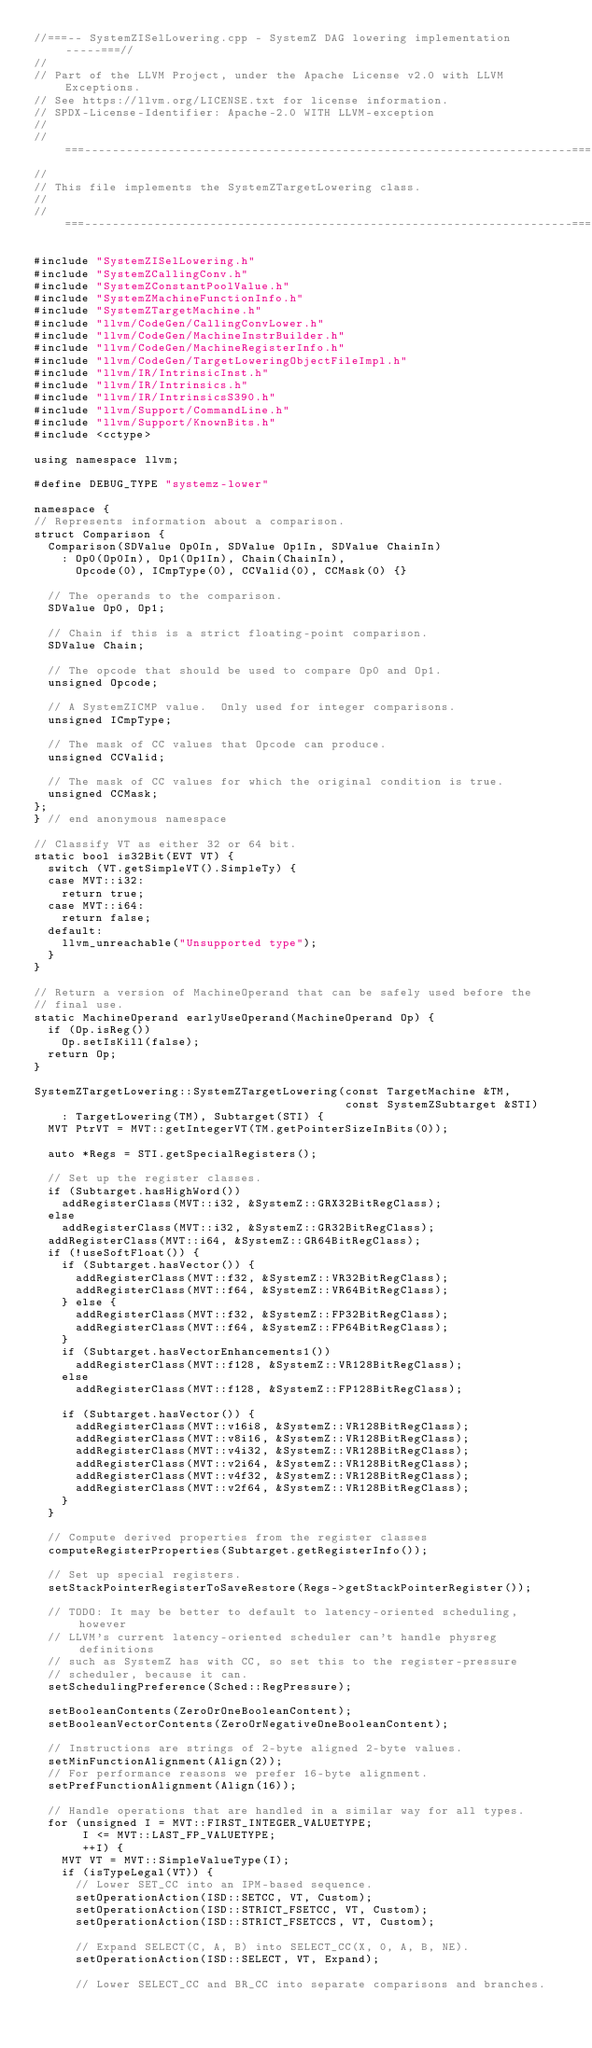Convert code to text. <code><loc_0><loc_0><loc_500><loc_500><_C++_>//===-- SystemZISelLowering.cpp - SystemZ DAG lowering implementation -----===//
//
// Part of the LLVM Project, under the Apache License v2.0 with LLVM Exceptions.
// See https://llvm.org/LICENSE.txt for license information.
// SPDX-License-Identifier: Apache-2.0 WITH LLVM-exception
//
//===----------------------------------------------------------------------===//
//
// This file implements the SystemZTargetLowering class.
//
//===----------------------------------------------------------------------===//

#include "SystemZISelLowering.h"
#include "SystemZCallingConv.h"
#include "SystemZConstantPoolValue.h"
#include "SystemZMachineFunctionInfo.h"
#include "SystemZTargetMachine.h"
#include "llvm/CodeGen/CallingConvLower.h"
#include "llvm/CodeGen/MachineInstrBuilder.h"
#include "llvm/CodeGen/MachineRegisterInfo.h"
#include "llvm/CodeGen/TargetLoweringObjectFileImpl.h"
#include "llvm/IR/IntrinsicInst.h"
#include "llvm/IR/Intrinsics.h"
#include "llvm/IR/IntrinsicsS390.h"
#include "llvm/Support/CommandLine.h"
#include "llvm/Support/KnownBits.h"
#include <cctype>

using namespace llvm;

#define DEBUG_TYPE "systemz-lower"

namespace {
// Represents information about a comparison.
struct Comparison {
  Comparison(SDValue Op0In, SDValue Op1In, SDValue ChainIn)
    : Op0(Op0In), Op1(Op1In), Chain(ChainIn),
      Opcode(0), ICmpType(0), CCValid(0), CCMask(0) {}

  // The operands to the comparison.
  SDValue Op0, Op1;

  // Chain if this is a strict floating-point comparison.
  SDValue Chain;

  // The opcode that should be used to compare Op0 and Op1.
  unsigned Opcode;

  // A SystemZICMP value.  Only used for integer comparisons.
  unsigned ICmpType;

  // The mask of CC values that Opcode can produce.
  unsigned CCValid;

  // The mask of CC values for which the original condition is true.
  unsigned CCMask;
};
} // end anonymous namespace

// Classify VT as either 32 or 64 bit.
static bool is32Bit(EVT VT) {
  switch (VT.getSimpleVT().SimpleTy) {
  case MVT::i32:
    return true;
  case MVT::i64:
    return false;
  default:
    llvm_unreachable("Unsupported type");
  }
}

// Return a version of MachineOperand that can be safely used before the
// final use.
static MachineOperand earlyUseOperand(MachineOperand Op) {
  if (Op.isReg())
    Op.setIsKill(false);
  return Op;
}

SystemZTargetLowering::SystemZTargetLowering(const TargetMachine &TM,
                                             const SystemZSubtarget &STI)
    : TargetLowering(TM), Subtarget(STI) {
  MVT PtrVT = MVT::getIntegerVT(TM.getPointerSizeInBits(0));

  auto *Regs = STI.getSpecialRegisters();

  // Set up the register classes.
  if (Subtarget.hasHighWord())
    addRegisterClass(MVT::i32, &SystemZ::GRX32BitRegClass);
  else
    addRegisterClass(MVT::i32, &SystemZ::GR32BitRegClass);
  addRegisterClass(MVT::i64, &SystemZ::GR64BitRegClass);
  if (!useSoftFloat()) {
    if (Subtarget.hasVector()) {
      addRegisterClass(MVT::f32, &SystemZ::VR32BitRegClass);
      addRegisterClass(MVT::f64, &SystemZ::VR64BitRegClass);
    } else {
      addRegisterClass(MVT::f32, &SystemZ::FP32BitRegClass);
      addRegisterClass(MVT::f64, &SystemZ::FP64BitRegClass);
    }
    if (Subtarget.hasVectorEnhancements1())
      addRegisterClass(MVT::f128, &SystemZ::VR128BitRegClass);
    else
      addRegisterClass(MVT::f128, &SystemZ::FP128BitRegClass);

    if (Subtarget.hasVector()) {
      addRegisterClass(MVT::v16i8, &SystemZ::VR128BitRegClass);
      addRegisterClass(MVT::v8i16, &SystemZ::VR128BitRegClass);
      addRegisterClass(MVT::v4i32, &SystemZ::VR128BitRegClass);
      addRegisterClass(MVT::v2i64, &SystemZ::VR128BitRegClass);
      addRegisterClass(MVT::v4f32, &SystemZ::VR128BitRegClass);
      addRegisterClass(MVT::v2f64, &SystemZ::VR128BitRegClass);
    }
  }

  // Compute derived properties from the register classes
  computeRegisterProperties(Subtarget.getRegisterInfo());

  // Set up special registers.
  setStackPointerRegisterToSaveRestore(Regs->getStackPointerRegister());

  // TODO: It may be better to default to latency-oriented scheduling, however
  // LLVM's current latency-oriented scheduler can't handle physreg definitions
  // such as SystemZ has with CC, so set this to the register-pressure
  // scheduler, because it can.
  setSchedulingPreference(Sched::RegPressure);

  setBooleanContents(ZeroOrOneBooleanContent);
  setBooleanVectorContents(ZeroOrNegativeOneBooleanContent);

  // Instructions are strings of 2-byte aligned 2-byte values.
  setMinFunctionAlignment(Align(2));
  // For performance reasons we prefer 16-byte alignment.
  setPrefFunctionAlignment(Align(16));

  // Handle operations that are handled in a similar way for all types.
  for (unsigned I = MVT::FIRST_INTEGER_VALUETYPE;
       I <= MVT::LAST_FP_VALUETYPE;
       ++I) {
    MVT VT = MVT::SimpleValueType(I);
    if (isTypeLegal(VT)) {
      // Lower SET_CC into an IPM-based sequence.
      setOperationAction(ISD::SETCC, VT, Custom);
      setOperationAction(ISD::STRICT_FSETCC, VT, Custom);
      setOperationAction(ISD::STRICT_FSETCCS, VT, Custom);

      // Expand SELECT(C, A, B) into SELECT_CC(X, 0, A, B, NE).
      setOperationAction(ISD::SELECT, VT, Expand);

      // Lower SELECT_CC and BR_CC into separate comparisons and branches.</code> 